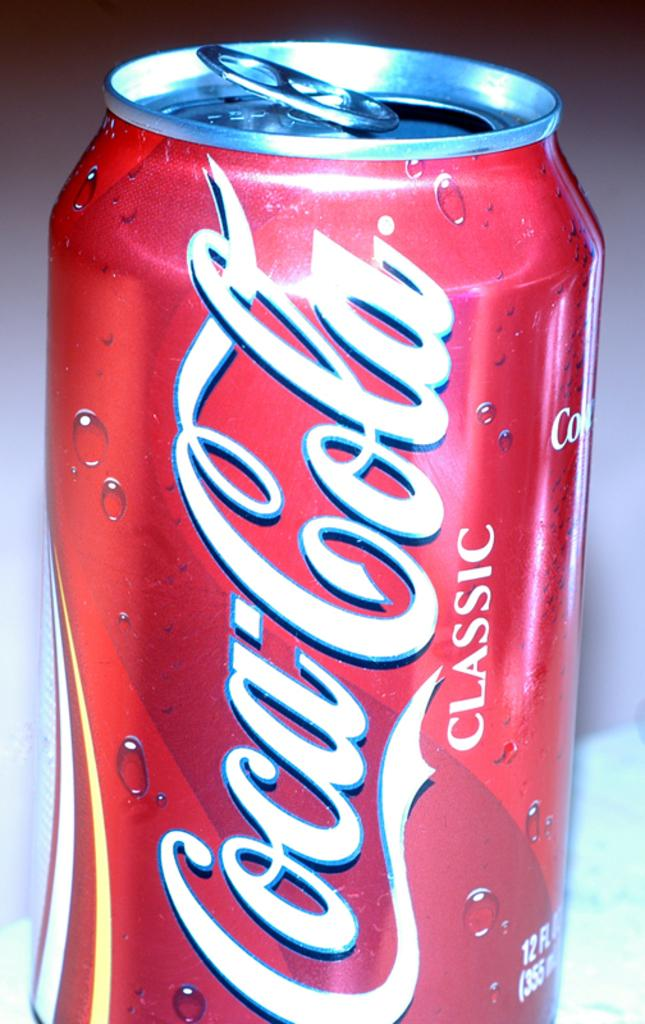<image>
Create a compact narrative representing the image presented. A red aluminum can of Coca-Cola classic soda. 